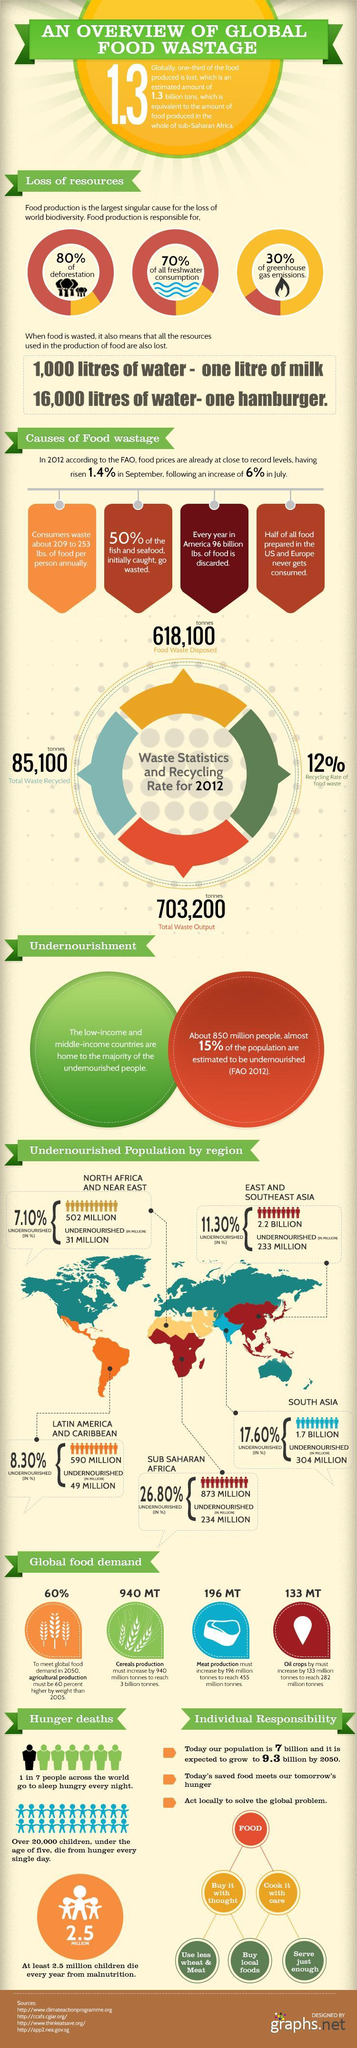How much oil crops is estimated to be required in 2050?
Answer the question with a short phrase. 282 million tonnes Half of which food items are wasted? Fish, Seafood Name the two regions responsible for the wastage of 50% of food ready to eat. US, Europe According to the report, what are the two items whose consumption must be reduced? Wheat, Meat What is the main reason for the loss of forest? Food production How much meat must be produced in 2050 to meet global food demand? 455 million tonnes What is the total undernourished population in million in east and southeast Asia and south Asia taken together? 537 million What is the target of cereals production by 2050? 3 billion tonnes What is the total undernourished population in million in north Africa and near east and Sub Saharan Africa taken together? 265 million 